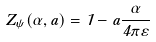Convert formula to latex. <formula><loc_0><loc_0><loc_500><loc_500>Z _ { \psi } ( \alpha , a ) = 1 - a \frac { \alpha } { 4 \pi \varepsilon }</formula> 